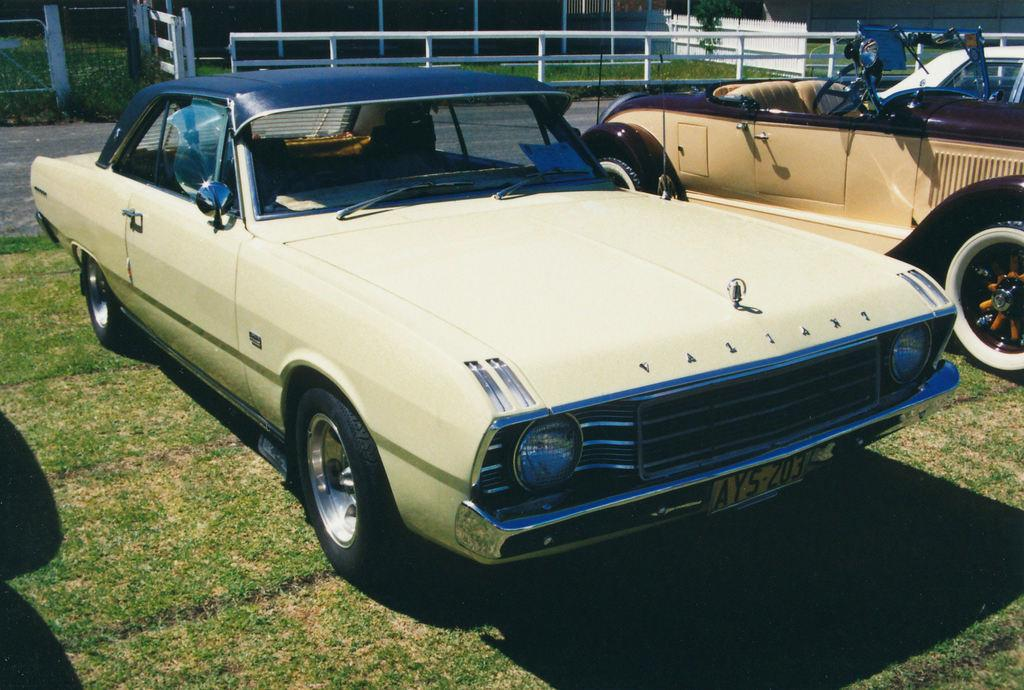How many vehicles can be seen on the ground in the image? There are two vehicles visible on the ground in the image. What is the other prominent feature visible in the image? There is a fence visible at the top of the image. What type of trouble is the tail experiencing in the image? There is no tail present in the image, so it is not possible to determine if any trouble is being experienced. 